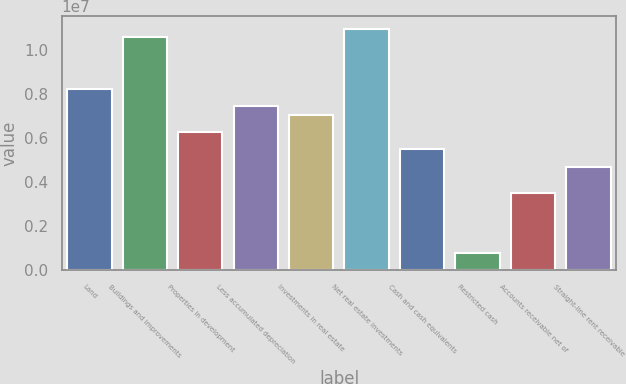Convert chart. <chart><loc_0><loc_0><loc_500><loc_500><bar_chart><fcel>Land<fcel>Buildings and improvements<fcel>Properties in development<fcel>Less accumulated depreciation<fcel>Investments in real estate<fcel>Net real estate investments<fcel>Cash and cash equivalents<fcel>Restricted cash<fcel>Accounts receivable net of<fcel>Straight-line rent receivable<nl><fcel>8.21737e+06<fcel>1.05649e+07<fcel>6.26107e+06<fcel>7.43485e+06<fcel>7.04359e+06<fcel>1.09562e+07<fcel>5.47855e+06<fcel>783442<fcel>3.52226e+06<fcel>4.69603e+06<nl></chart> 